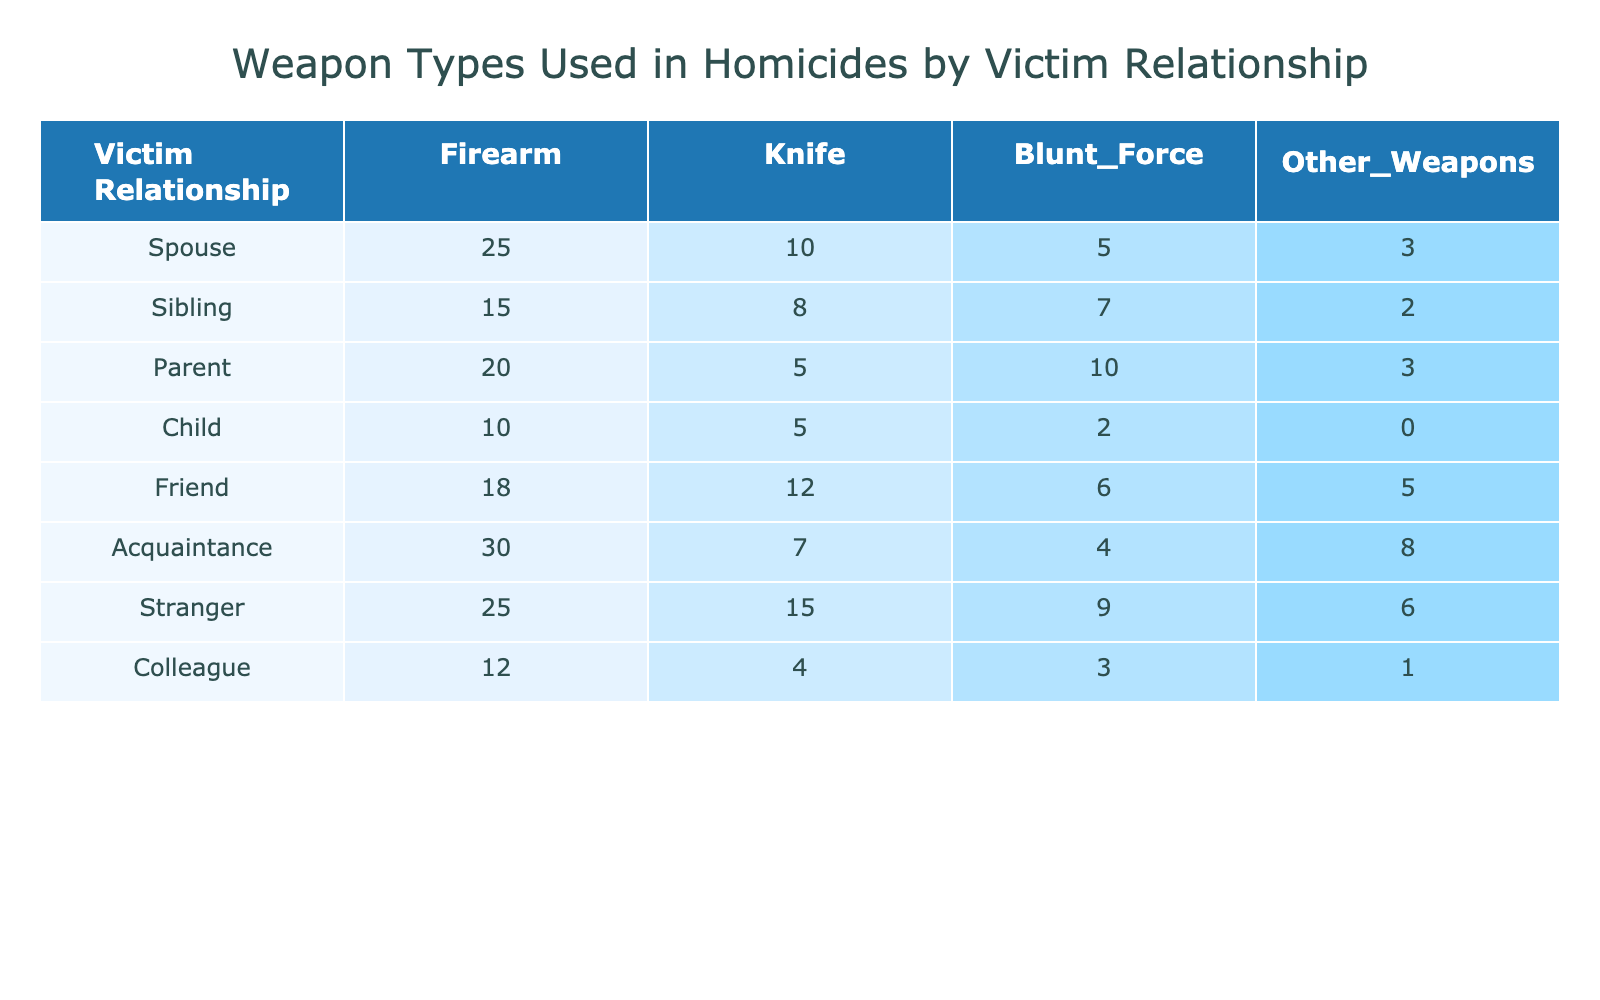What is the total number of homicides involving firearms for the spouse relationship? Referring to the table, the count of homicides involving firearms for the spouse is directly listed as 25.
Answer: 25 What is the count of homicides using knives with acquaintances? In the table, the count for homicides involving knives under the acquaintance relationship is shown as 7.
Answer: 7 Which victim relationship has the highest number of blunt-force homicides? By examining the blunt-force column, the sibling relationship shows the highest count of 7 compared to others.
Answer: Sibling Is the total number of homicides with firearms greater than the total with knives across all relationships? To find this, we sum the firearms counts (25 + 15 + 20 + 10 + 18 + 30 + 25 + 12) = 155, and knife counts (10 + 8 + 5 + 5 + 12 + 7 + 15 + 4) = 66. Since 155 > 66, the statement is true.
Answer: Yes How many more homicides involving 'other weapons' are there in the 'stranger' category compared to the 'child' category? Looking at the table, the stranger category has 6 homicides with other weapons, while the child category has 0. The difference is 6 - 0 = 6.
Answer: 6 Which weapon type is most commonly associated with victims who are siblings? Checking the table, siblings show the highest count with knives at 8 compared to other weapon types (firearm, blunt force, other).
Answer: Knife Is it true that colleagues have more homicides due to blunt force than spouses? Checking the counts, colleagues have 3 blunt-force homicides while spouses have 5. Since 3 is not greater than 5, the statement is false.
Answer: No What is the average number of homicides involving firearms across all victim relationships? To find the average, sum the firearm counts (25 + 15 + 20 + 10 + 18 + 30 + 25 + 12) = 155. There are 8 relationships, so the average is 155 / 8 = 19.375.
Answer: 19.375 Which victim relationship has the lowest total homicide counts when summing all weapon types? For total counts per relationship: Spouse (43), Sibling (32), Parent (38), Child (17), Friend (41), Acquaintance (49), Stranger (55), Colleague (20). The child relationship has the lowest total of 17.
Answer: Child 